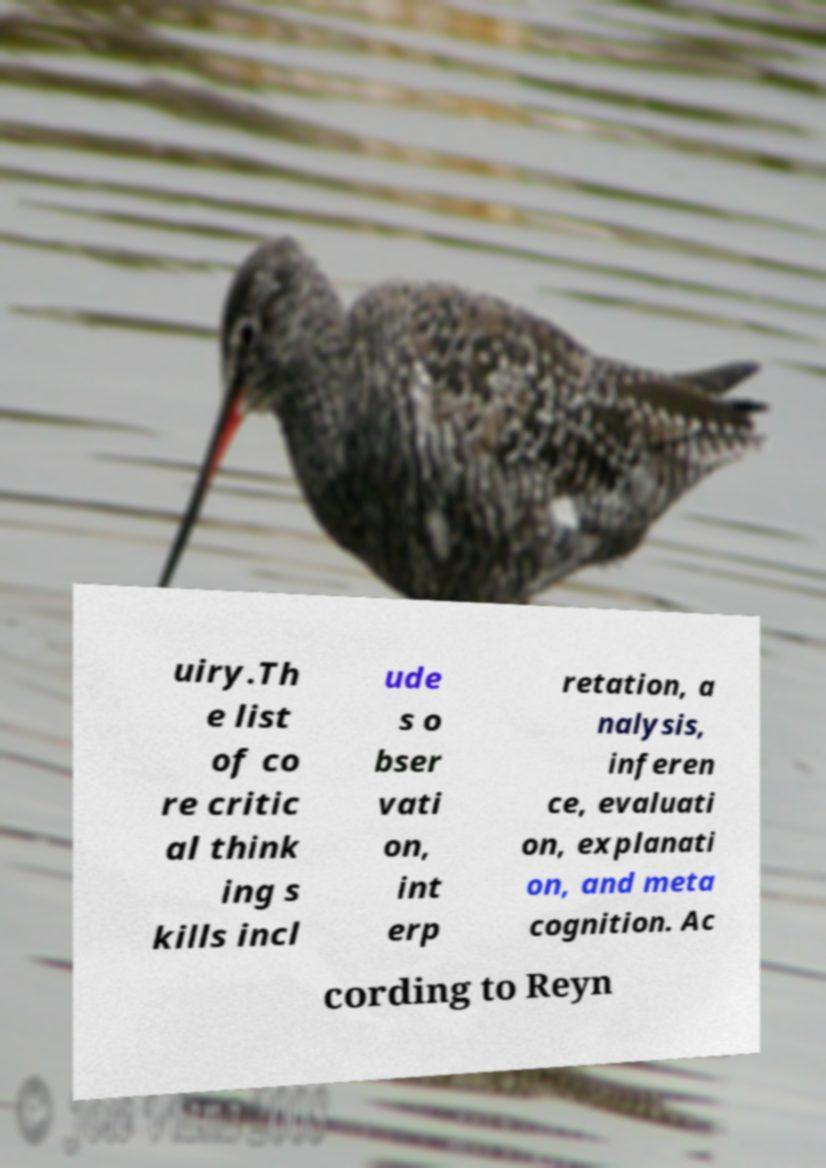Please read and relay the text visible in this image. What does it say? uiry.Th e list of co re critic al think ing s kills incl ude s o bser vati on, int erp retation, a nalysis, inferen ce, evaluati on, explanati on, and meta cognition. Ac cording to Reyn 